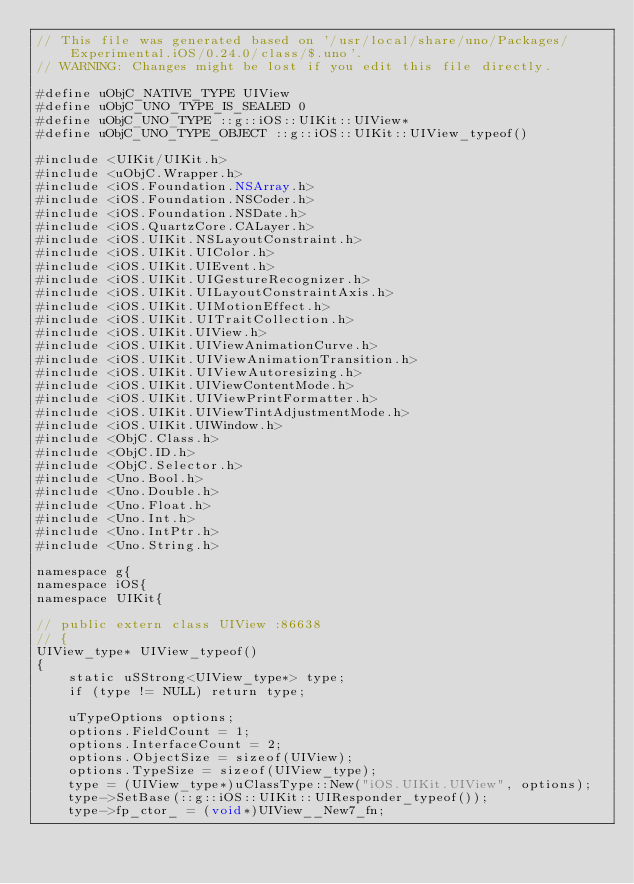Convert code to text. <code><loc_0><loc_0><loc_500><loc_500><_ObjectiveC_>// This file was generated based on '/usr/local/share/uno/Packages/Experimental.iOS/0.24.0/class/$.uno'.
// WARNING: Changes might be lost if you edit this file directly.

#define uObjC_NATIVE_TYPE UIView
#define uObjC_UNO_TYPE_IS_SEALED 0
#define uObjC_UNO_TYPE ::g::iOS::UIKit::UIView*
#define uObjC_UNO_TYPE_OBJECT ::g::iOS::UIKit::UIView_typeof()

#include <UIKit/UIKit.h>
#include <uObjC.Wrapper.h>
#include <iOS.Foundation.NSArray.h>
#include <iOS.Foundation.NSCoder.h>
#include <iOS.Foundation.NSDate.h>
#include <iOS.QuartzCore.CALayer.h>
#include <iOS.UIKit.NSLayoutConstraint.h>
#include <iOS.UIKit.UIColor.h>
#include <iOS.UIKit.UIEvent.h>
#include <iOS.UIKit.UIGestureRecognizer.h>
#include <iOS.UIKit.UILayoutConstraintAxis.h>
#include <iOS.UIKit.UIMotionEffect.h>
#include <iOS.UIKit.UITraitCollection.h>
#include <iOS.UIKit.UIView.h>
#include <iOS.UIKit.UIViewAnimationCurve.h>
#include <iOS.UIKit.UIViewAnimationTransition.h>
#include <iOS.UIKit.UIViewAutoresizing.h>
#include <iOS.UIKit.UIViewContentMode.h>
#include <iOS.UIKit.UIViewPrintFormatter.h>
#include <iOS.UIKit.UIViewTintAdjustmentMode.h>
#include <iOS.UIKit.UIWindow.h>
#include <ObjC.Class.h>
#include <ObjC.ID.h>
#include <ObjC.Selector.h>
#include <Uno.Bool.h>
#include <Uno.Double.h>
#include <Uno.Float.h>
#include <Uno.Int.h>
#include <Uno.IntPtr.h>
#include <Uno.String.h>

namespace g{
namespace iOS{
namespace UIKit{

// public extern class UIView :86638
// {
UIView_type* UIView_typeof()
{
    static uSStrong<UIView_type*> type;
    if (type != NULL) return type;

    uTypeOptions options;
    options.FieldCount = 1;
    options.InterfaceCount = 2;
    options.ObjectSize = sizeof(UIView);
    options.TypeSize = sizeof(UIView_type);
    type = (UIView_type*)uClassType::New("iOS.UIKit.UIView", options);
    type->SetBase(::g::iOS::UIKit::UIResponder_typeof());
    type->fp_ctor_ = (void*)UIView__New7_fn;</code> 